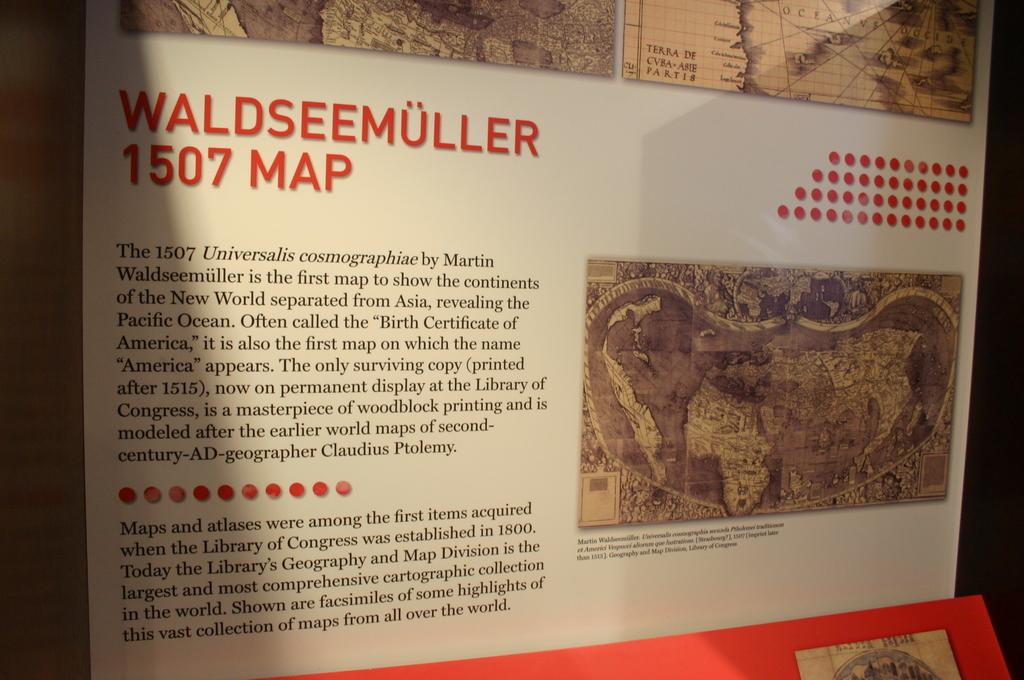How many maps are available?
Ensure brevity in your answer.  1507. What is the significance of the 1507 waldseemuller map?
Ensure brevity in your answer.  First map to show the continents of the new world. 